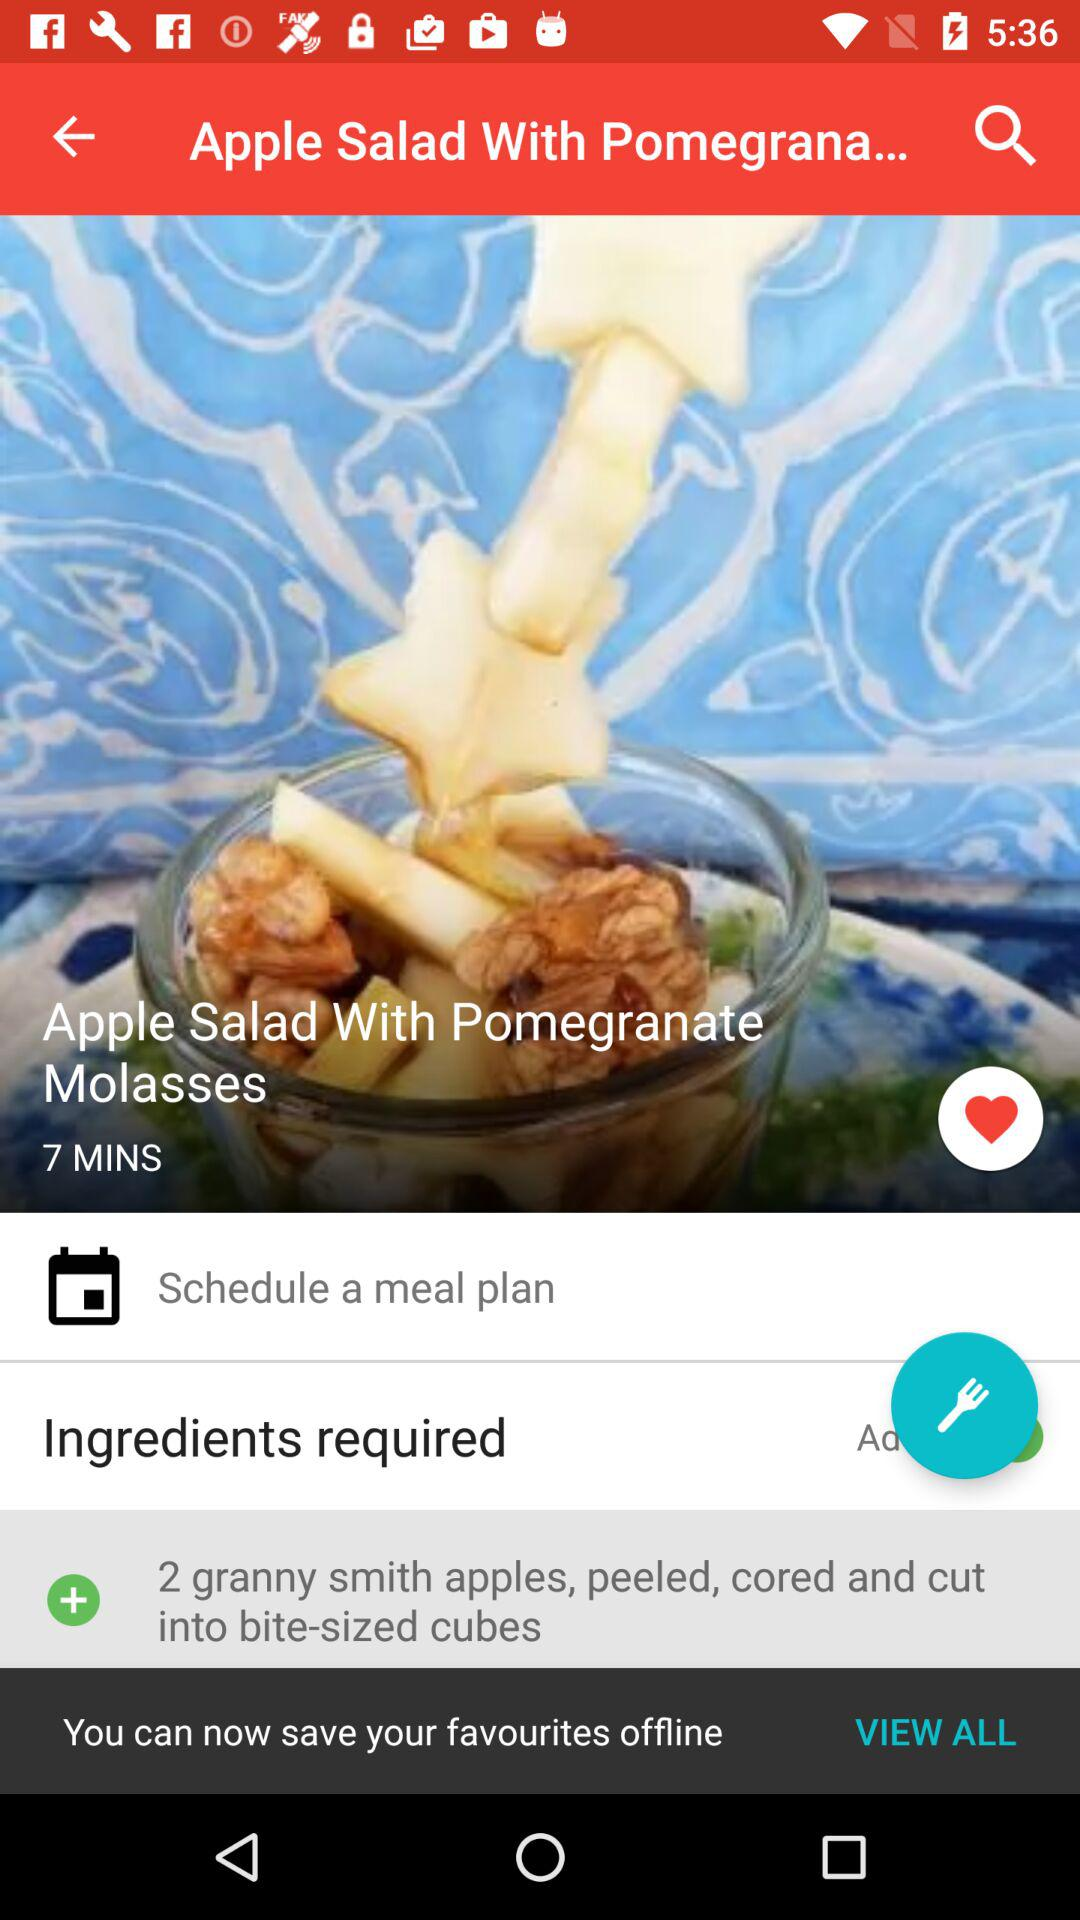How much pomegranate molasses is required?
When the provided information is insufficient, respond with <no answer>. <no answer> 